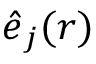<formula> <loc_0><loc_0><loc_500><loc_500>\hat { e } _ { j } ( r )</formula> 